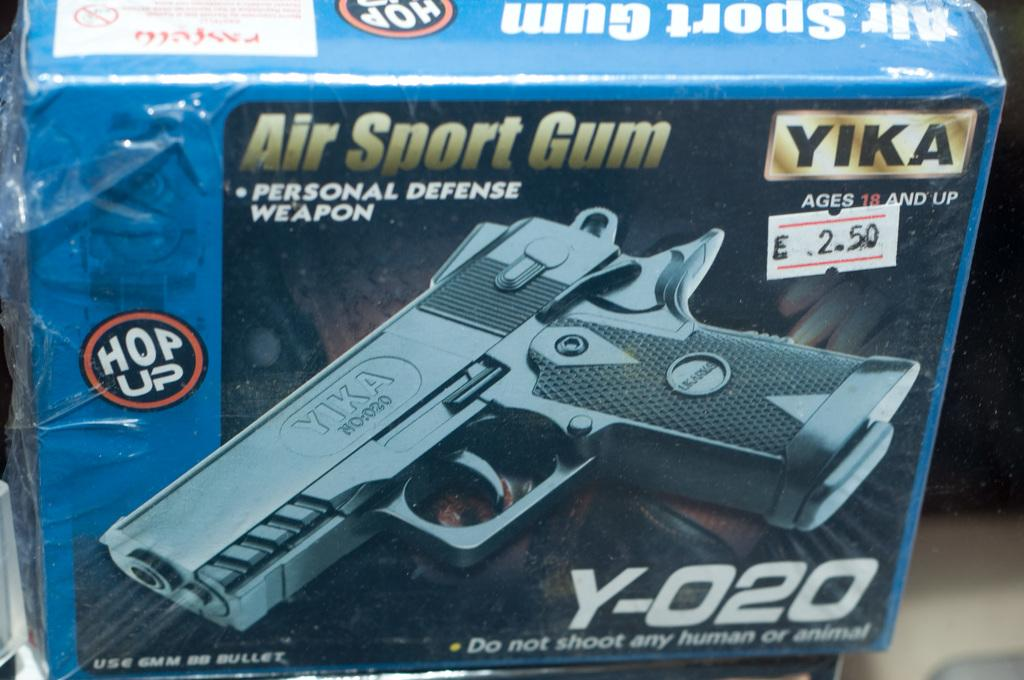What is the main object in the image? There is a box of personal defense weapon in the image. Can you describe the object in more detail? The object is a box containing a personal defense weapon, which is typically used for self-protection. What type of crack is present in the image? There is no crack present in the image; it features a box of personal defense weapon. What trick can be performed with the personal defense weapon in the image? The image does not depict any tricks or performances involving the personal defense weapon. 